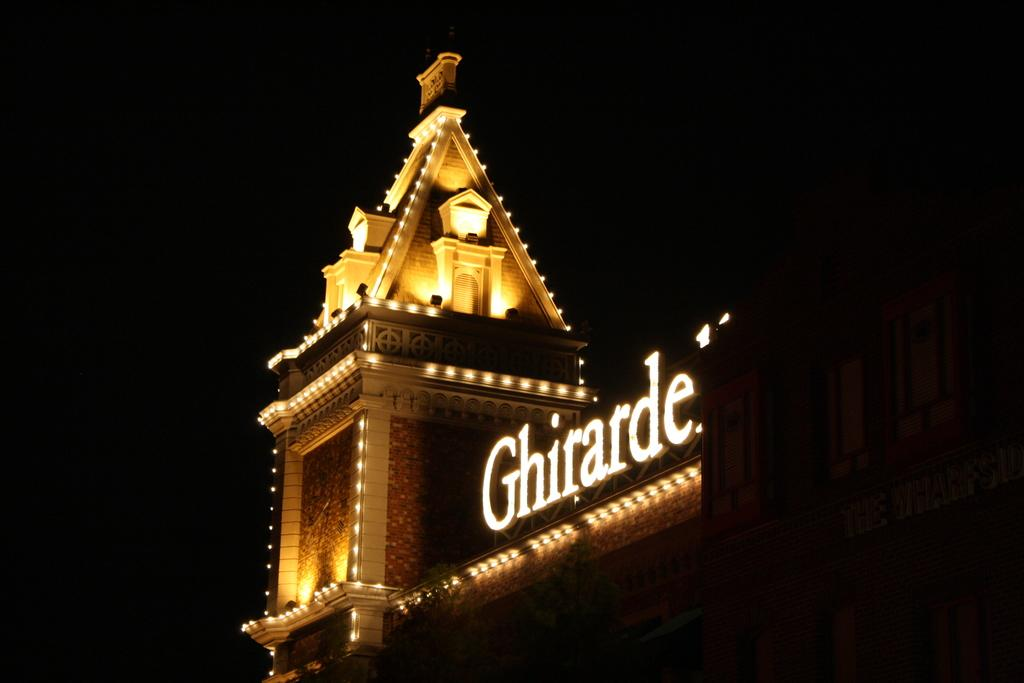What is the main structure visible in the image? There is a building in the image. What feature of the building is mentioned in the facts? The building has lights, and there is text with lights on the building. How would you describe the background of the image? The background of the image is dark. What type of silk is being used to hold the liquid in the image? There is no silk or liquid present in the image; it features a building with lights and text. 